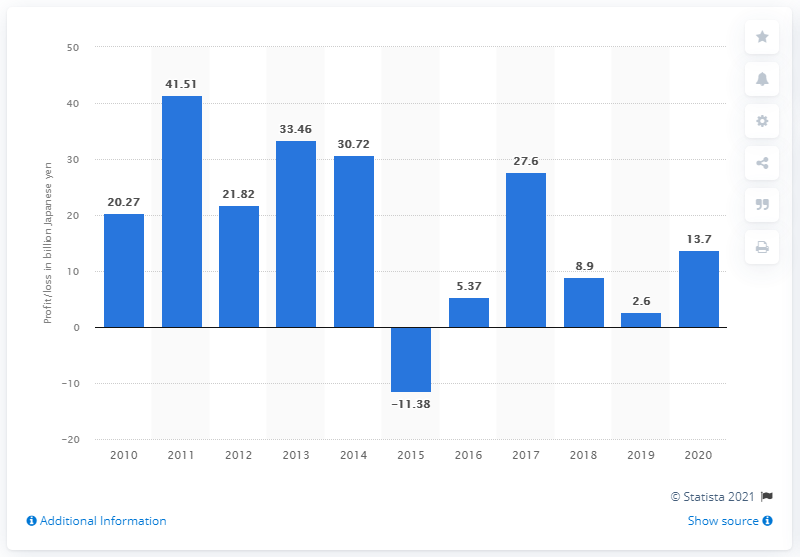Draw attention to some important aspects in this diagram. Sega Sammy's profit for the last fiscal year that ended on March 31, 2020 was 13.7 billion yen. 